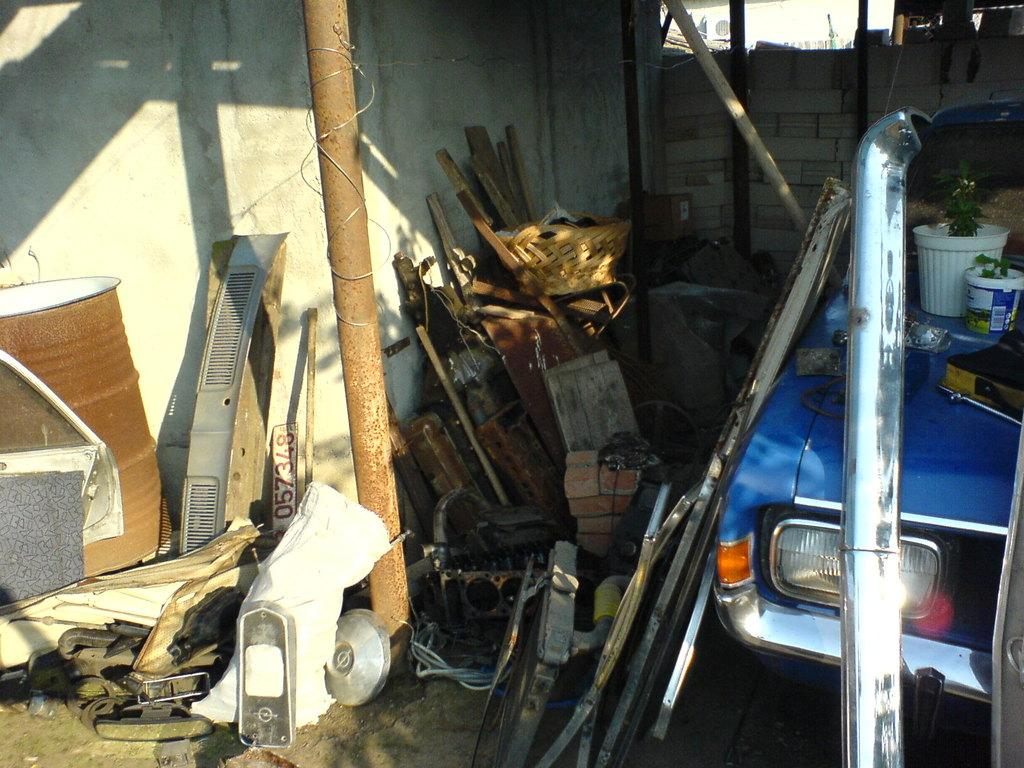What type of materials can be seen in the image? There are iron scraps in the image. What object is present that is typically used for making noise? There is a drum in the image. What type of vehicle is visible in the image? There is a blue car in the image. What type of structure can be seen in the background of the image? There is a brick wall in the background of the image. Where is the pencil located in the image? There is no pencil present in the image. Does the existence of the iron scraps in the image prove the existence of a playground? The presence of iron scraps in the image does not prove the existence of a playground, as there is no information about the location or context of the image. 